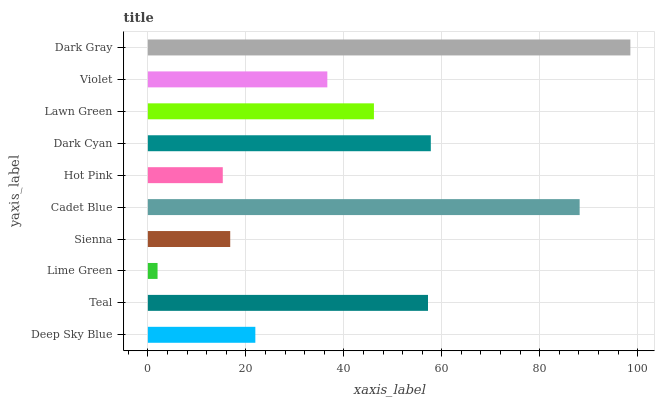Is Lime Green the minimum?
Answer yes or no. Yes. Is Dark Gray the maximum?
Answer yes or no. Yes. Is Teal the minimum?
Answer yes or no. No. Is Teal the maximum?
Answer yes or no. No. Is Teal greater than Deep Sky Blue?
Answer yes or no. Yes. Is Deep Sky Blue less than Teal?
Answer yes or no. Yes. Is Deep Sky Blue greater than Teal?
Answer yes or no. No. Is Teal less than Deep Sky Blue?
Answer yes or no. No. Is Lawn Green the high median?
Answer yes or no. Yes. Is Violet the low median?
Answer yes or no. Yes. Is Deep Sky Blue the high median?
Answer yes or no. No. Is Lime Green the low median?
Answer yes or no. No. 